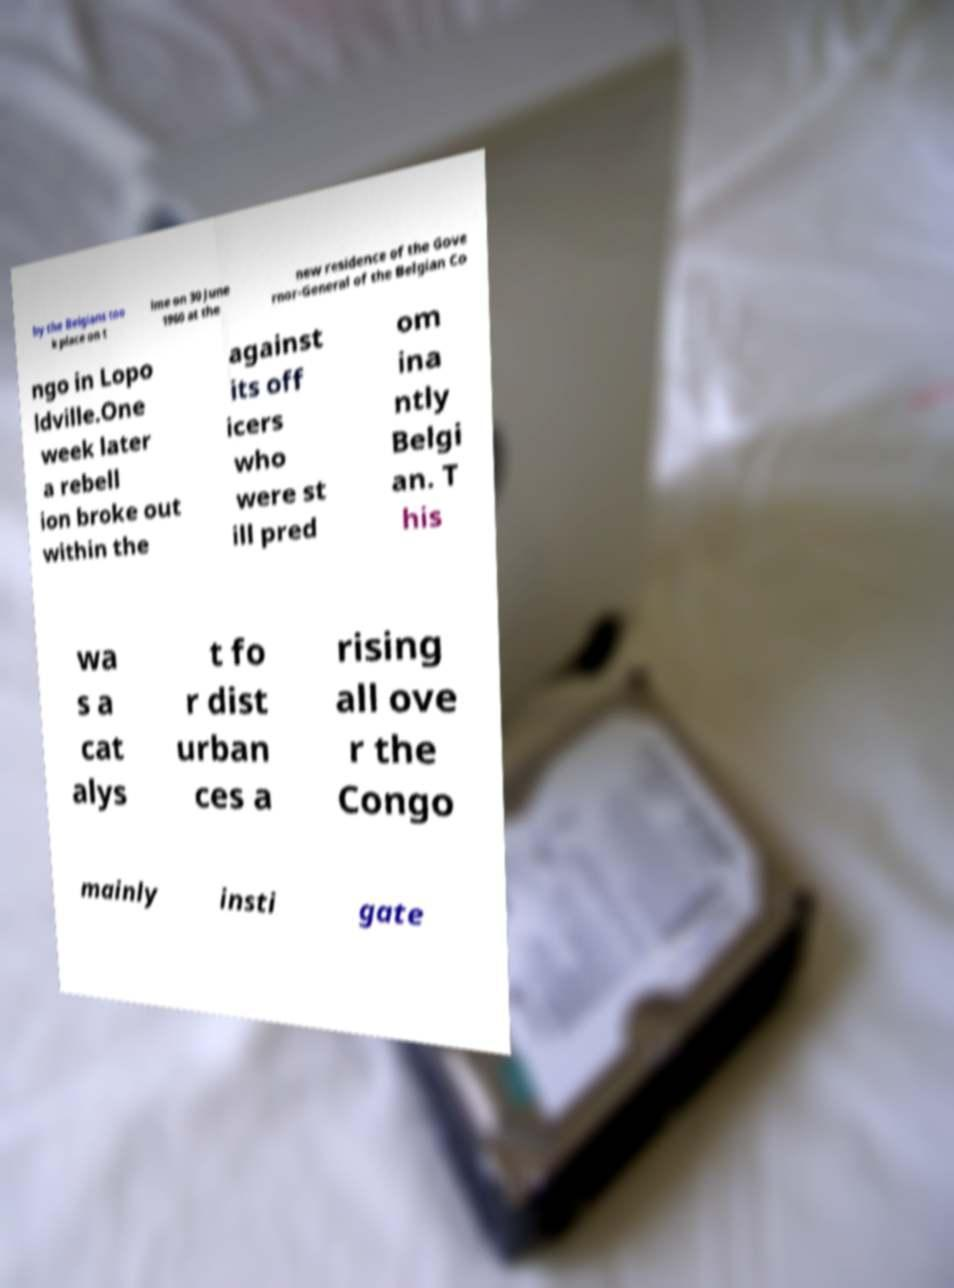Can you accurately transcribe the text from the provided image for me? by the Belgians too k place on t ime on 30 June 1960 at the new residence of the Gove rnor-General of the Belgian Co ngo in Lopo ldville.One week later a rebell ion broke out within the against its off icers who were st ill pred om ina ntly Belgi an. T his wa s a cat alys t fo r dist urban ces a rising all ove r the Congo mainly insti gate 